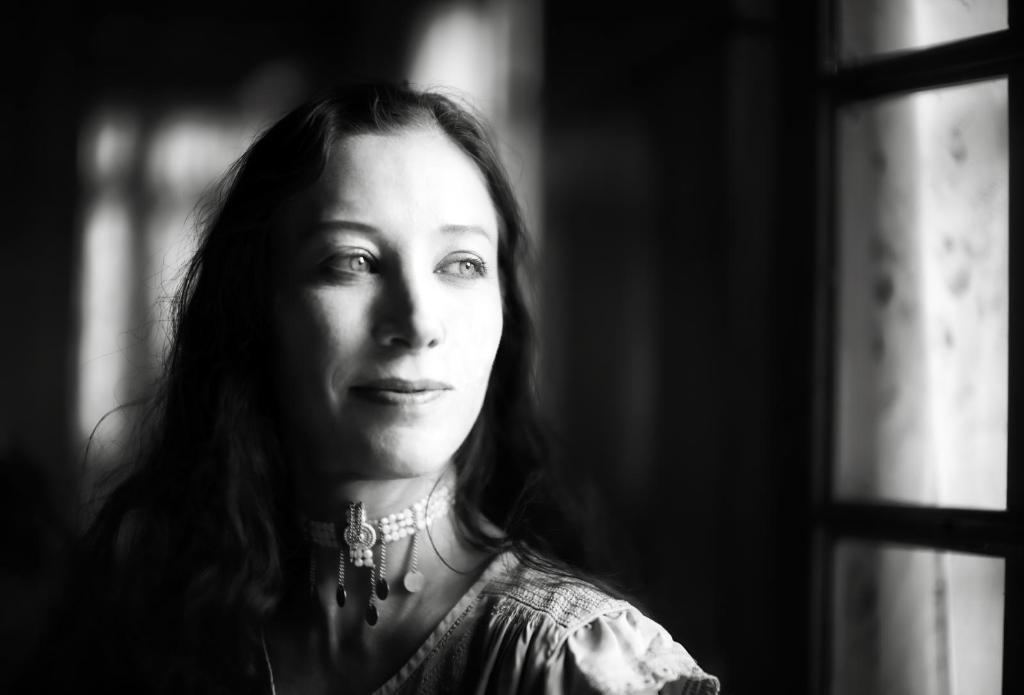Describe this image in one or two sentences. In this picture we can see a woman is smiling in the front, there is a blurry background, it is a black and white image. 